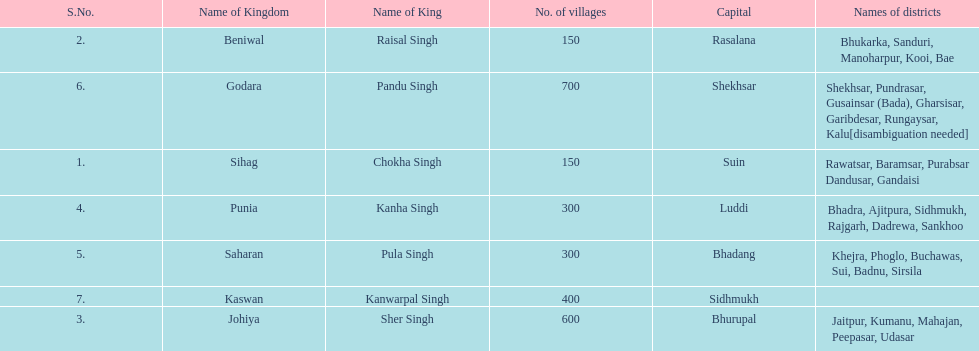He was the king of the sihag kingdom. Chokha Singh. 